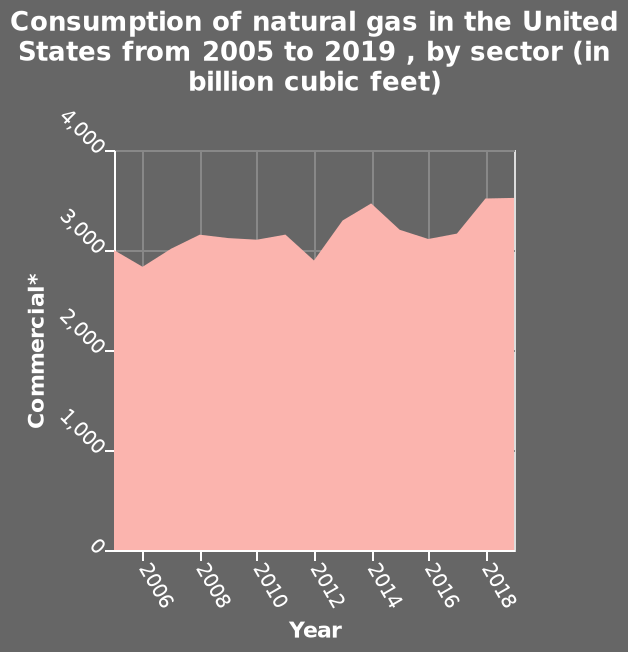<image>
Is the consumption of natural gas in the US constant over time?  No, the consumption of natural gas in the US is not constant, it is gradually increasing. What unit is used to measure natural gas consumption? Natural gas consumption is measured in billion cubic feet. How would you describe the pattern of natural gas consumption in the US? The pattern of natural gas consumption in the US shows intermittent fluctuations with an overall upward trend. Are there fluctuations in the consumption of natural gas in the US?  Yes, there are peaks and troughs in the consumption of natural gas in the US. 